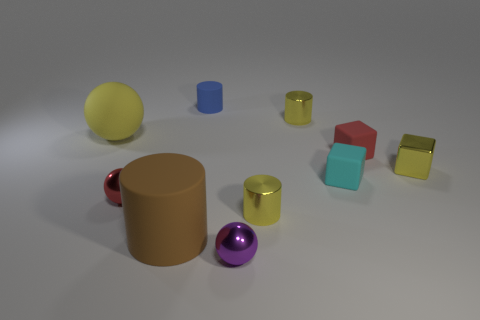Subtract all brown cylinders. How many cylinders are left? 3 Subtract all shiny balls. How many balls are left? 1 Subtract 1 blocks. How many blocks are left? 2 Subtract all purple cylinders. Subtract all blue blocks. How many cylinders are left? 4 Subtract all spheres. How many objects are left? 7 Subtract all tiny purple shiny things. Subtract all tiny yellow shiny cylinders. How many objects are left? 7 Add 5 small yellow shiny blocks. How many small yellow shiny blocks are left? 6 Add 2 purple objects. How many purple objects exist? 3 Subtract 1 brown cylinders. How many objects are left? 9 